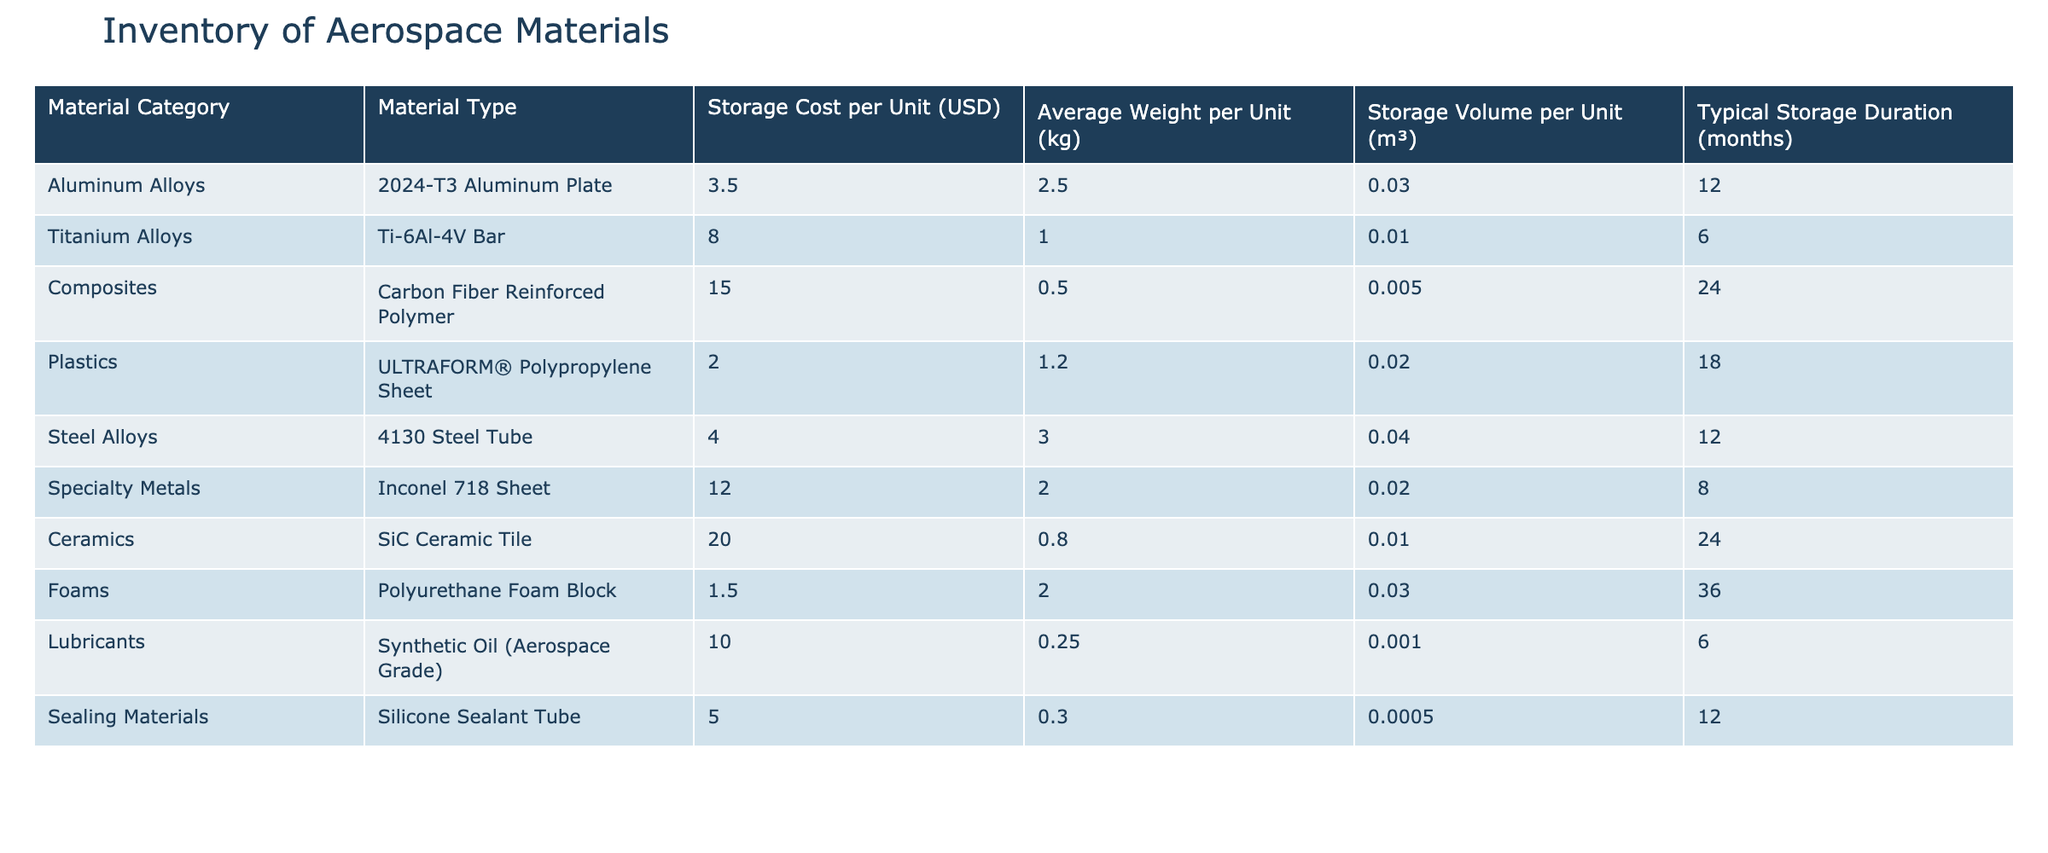What is the storage cost per unit for the Composite category? The storage cost per unit for the Composite category is listed in the table, specifically for the Carbon Fiber Reinforced Polymer material, which shows a value of 15.00 USD.
Answer: 15.00 USD Which material type has the highest storage cost per unit? To identify the material type with the highest storage cost, we can compare the storage cost per unit for all material types listed. In this case, the SiC Ceramic Tile has the highest storage cost at 20.00 USD.
Answer: SiC Ceramic Tile Calculate the average storage cost per unit for Aluminum Alloys and Steel Alloys. The storage costs for Aluminum Alloys and Steel Alloys are 3.50 USD and 4.00 USD, respectively. Their sum is 7.50 USD, and there are 2 types, so the average storage cost is 7.50 USD / 2 = 3.75 USD.
Answer: 3.75 USD Is the Typical Storage Duration for Lubricants longer than for Titan Alloys? The typical storage duration for Lubricants is 6 months, while for Titanium Alloys it is also 6 months. Since they are equal, the answer is no.
Answer: No How much heavier, on average, is the material from the Composites category compared to the material from the Plastics category? The average weight for Carbon Fiber Reinforced Polymer in Composites is 0.5 kg, while for ULTRAFORM® Polypropylene Sheet in Plastics it is 1.2 kg. The difference is 1.2 kg - 0.5 kg = 0.7 kg, indicating that Plastics are heavier on average.
Answer: 0.7 kg What percentage of the storage volume per unit is occupied by the 2024-T3 Aluminum Plate compared to the SiC Ceramic Tile? The volume for 2024-T3 Aluminum Plate is 0.03 m³, and for SiC Ceramic Tile, it is 0.01 m³. The percentage is calculated as (0.03 m³ / 0.01 m³) * 100 = 300%.
Answer: 300% Which material category has the longest typical storage duration? The longest typical storage duration can be found by reviewing the durations listed for each category. The longest time is 36 months for Foams, making it the correct answer.
Answer: Foams Is the average weight of a unit in the Specialty Metals category greater than that in the Plastics category? The average weight for Inconel 718 Sheet in Specialty Metals is 2.0 kg, whereas for ULTRAFORM® Polypropylene Sheet in Plastics, it is 1.2 kg. Since 2.0 kg is greater than 1.2 kg, the answer is yes.
Answer: Yes 